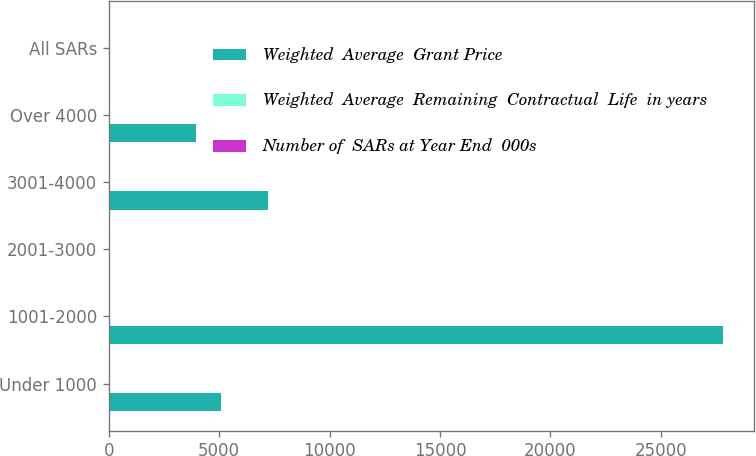<chart> <loc_0><loc_0><loc_500><loc_500><stacked_bar_chart><ecel><fcel>Under 1000<fcel>1001-2000<fcel>2001-3000<fcel>3001-4000<fcel>Over 4000<fcel>All SARs<nl><fcel>Weighted  Average  Grant Price<fcel>5100<fcel>27812<fcel>34<fcel>7231<fcel>3943<fcel>20.41<nl><fcel>Weighted  Average  Remaining  Contractual  Life  in years<fcel>4.06<fcel>14.98<fcel>22.88<fcel>38.69<fcel>46.37<fcel>20.41<nl><fcel>Number of  SARs at Year End  000s<fcel>6.3<fcel>8<fcel>5.2<fcel>3.6<fcel>2.2<fcel>6.6<nl></chart> 